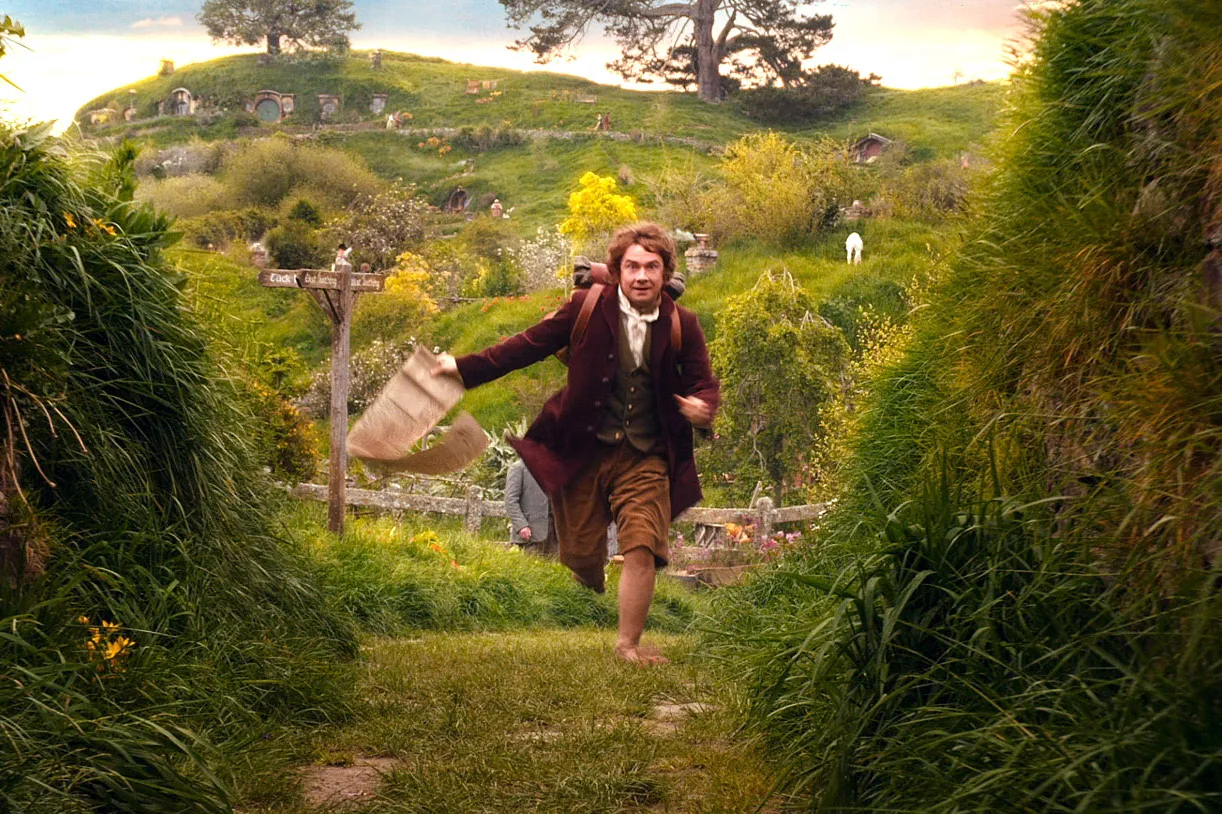Describe the setting and the mood of the image. The setting is the idyllic Shire, known for its tranquil and charming countryside. The green hills are dotted with cozy hobbit holes, which are seamlessly integrated into the natural landscape. The mood of the image is a blend of urgency and serenity. The character's swift movement contrasts with the peaceful environment, suggesting a moment of adventure amidst the normally serene life in the Shire. 